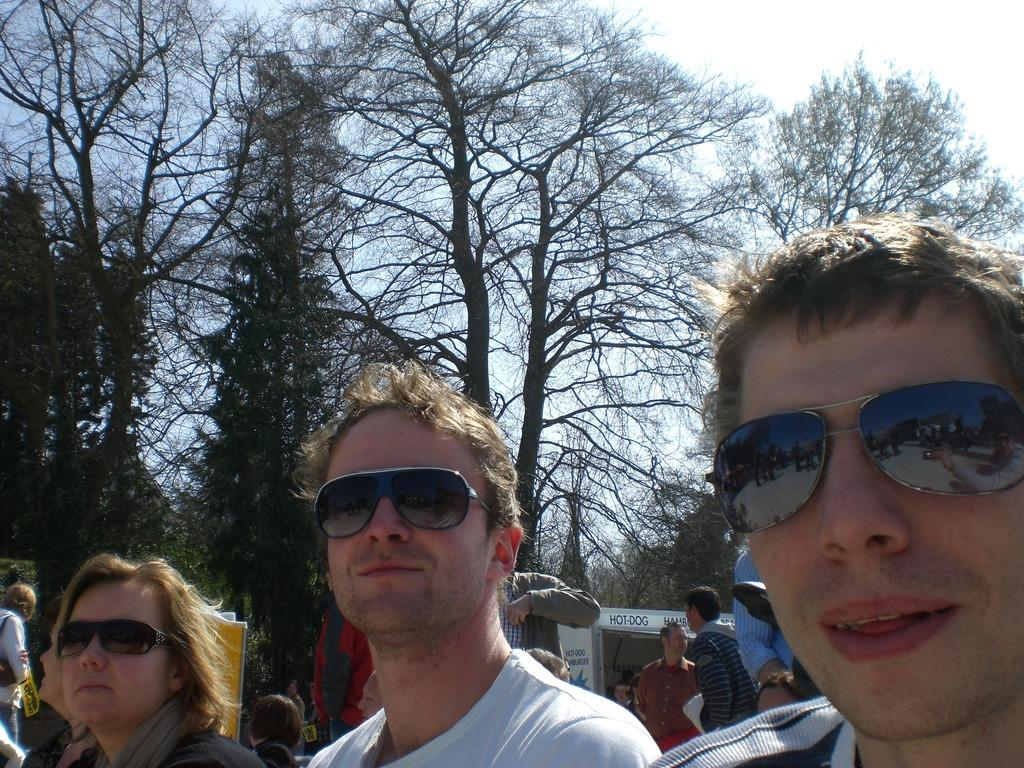<image>
Provide a brief description of the given image. Two men are taking a picture in front of a hot dog truck. 